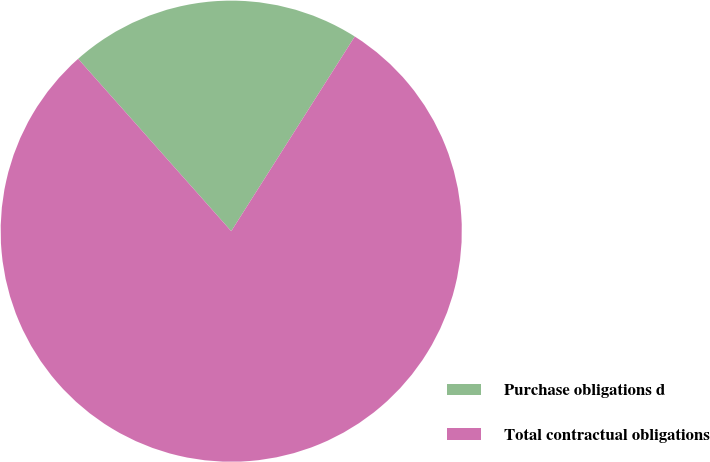Convert chart. <chart><loc_0><loc_0><loc_500><loc_500><pie_chart><fcel>Purchase obligations d<fcel>Total contractual obligations<nl><fcel>20.56%<fcel>79.44%<nl></chart> 